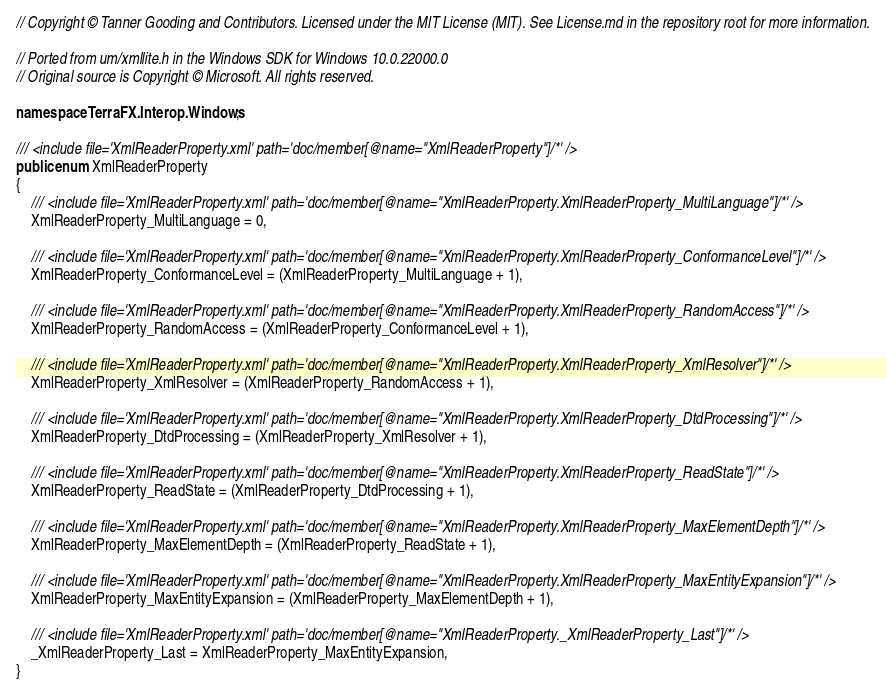<code> <loc_0><loc_0><loc_500><loc_500><_C#_>// Copyright © Tanner Gooding and Contributors. Licensed under the MIT License (MIT). See License.md in the repository root for more information.

// Ported from um/xmllite.h in the Windows SDK for Windows 10.0.22000.0
// Original source is Copyright © Microsoft. All rights reserved.

namespace TerraFX.Interop.Windows;

/// <include file='XmlReaderProperty.xml' path='doc/member[@name="XmlReaderProperty"]/*' />
public enum XmlReaderProperty
{
    /// <include file='XmlReaderProperty.xml' path='doc/member[@name="XmlReaderProperty.XmlReaderProperty_MultiLanguage"]/*' />
    XmlReaderProperty_MultiLanguage = 0,

    /// <include file='XmlReaderProperty.xml' path='doc/member[@name="XmlReaderProperty.XmlReaderProperty_ConformanceLevel"]/*' />
    XmlReaderProperty_ConformanceLevel = (XmlReaderProperty_MultiLanguage + 1),

    /// <include file='XmlReaderProperty.xml' path='doc/member[@name="XmlReaderProperty.XmlReaderProperty_RandomAccess"]/*' />
    XmlReaderProperty_RandomAccess = (XmlReaderProperty_ConformanceLevel + 1),

    /// <include file='XmlReaderProperty.xml' path='doc/member[@name="XmlReaderProperty.XmlReaderProperty_XmlResolver"]/*' />
    XmlReaderProperty_XmlResolver = (XmlReaderProperty_RandomAccess + 1),

    /// <include file='XmlReaderProperty.xml' path='doc/member[@name="XmlReaderProperty.XmlReaderProperty_DtdProcessing"]/*' />
    XmlReaderProperty_DtdProcessing = (XmlReaderProperty_XmlResolver + 1),

    /// <include file='XmlReaderProperty.xml' path='doc/member[@name="XmlReaderProperty.XmlReaderProperty_ReadState"]/*' />
    XmlReaderProperty_ReadState = (XmlReaderProperty_DtdProcessing + 1),

    /// <include file='XmlReaderProperty.xml' path='doc/member[@name="XmlReaderProperty.XmlReaderProperty_MaxElementDepth"]/*' />
    XmlReaderProperty_MaxElementDepth = (XmlReaderProperty_ReadState + 1),

    /// <include file='XmlReaderProperty.xml' path='doc/member[@name="XmlReaderProperty.XmlReaderProperty_MaxEntityExpansion"]/*' />
    XmlReaderProperty_MaxEntityExpansion = (XmlReaderProperty_MaxElementDepth + 1),

    /// <include file='XmlReaderProperty.xml' path='doc/member[@name="XmlReaderProperty._XmlReaderProperty_Last"]/*' />
    _XmlReaderProperty_Last = XmlReaderProperty_MaxEntityExpansion,
}
</code> 